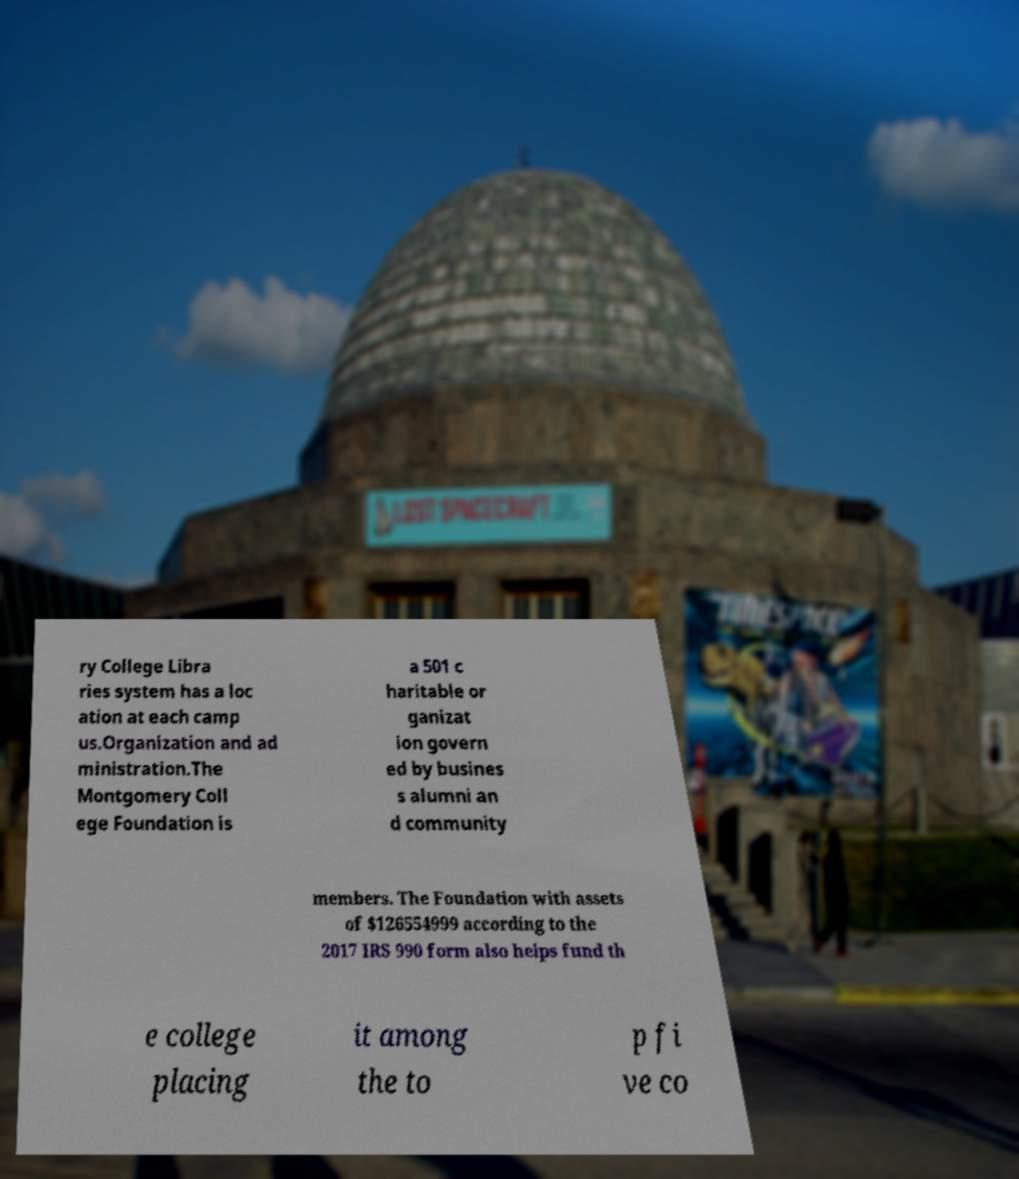For documentation purposes, I need the text within this image transcribed. Could you provide that? ry College Libra ries system has a loc ation at each camp us.Organization and ad ministration.The Montgomery Coll ege Foundation is a 501 c haritable or ganizat ion govern ed by busines s alumni an d community members. The Foundation with assets of $126554999 according to the 2017 IRS 990 form also helps fund th e college placing it among the to p fi ve co 